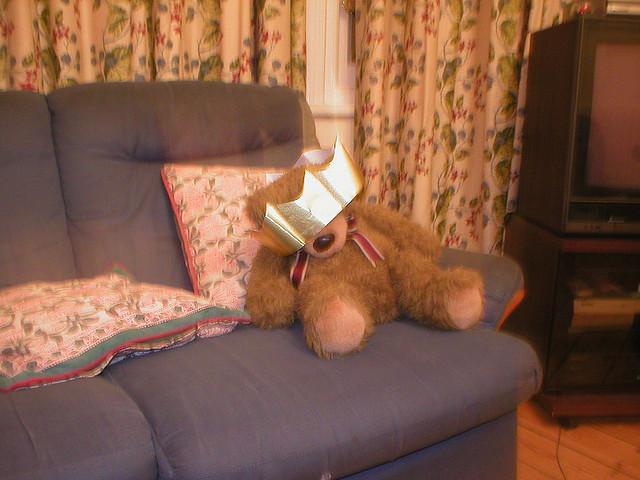Would the television have a HDMI connection?
Keep it brief. No. How many pillows are on the couch?
Answer briefly. 2. What is on the bears head?
Concise answer only. Crown. 